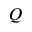<formula> <loc_0><loc_0><loc_500><loc_500>Q</formula> 